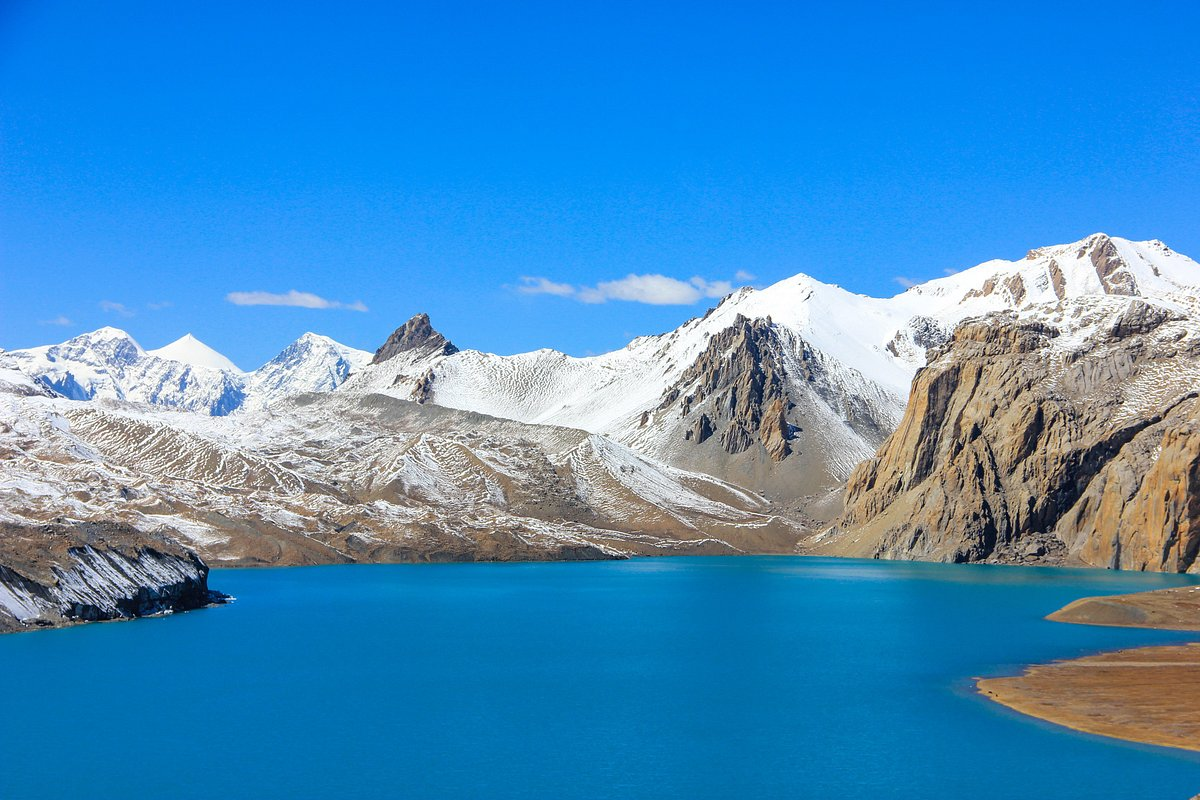How might the seasons affect the appearance of this place? In the spring and summer, the snow on the mountains might melt significantly, revealing more of the rugged landscape and possibly increasing the water level of the lake. Vegetation, although sparse in such an alpine environment, may show signs of life with hardy shrubs or alpine flowers blooming. During autumn, the area may experience a transitional phase with cold temperatures starting to set in, leading to the first snowfalls. In winter, the scene transforms dramatically as heavy snow blankets the ground, and the lake could freeze over, depending on its altitude and temperature. 